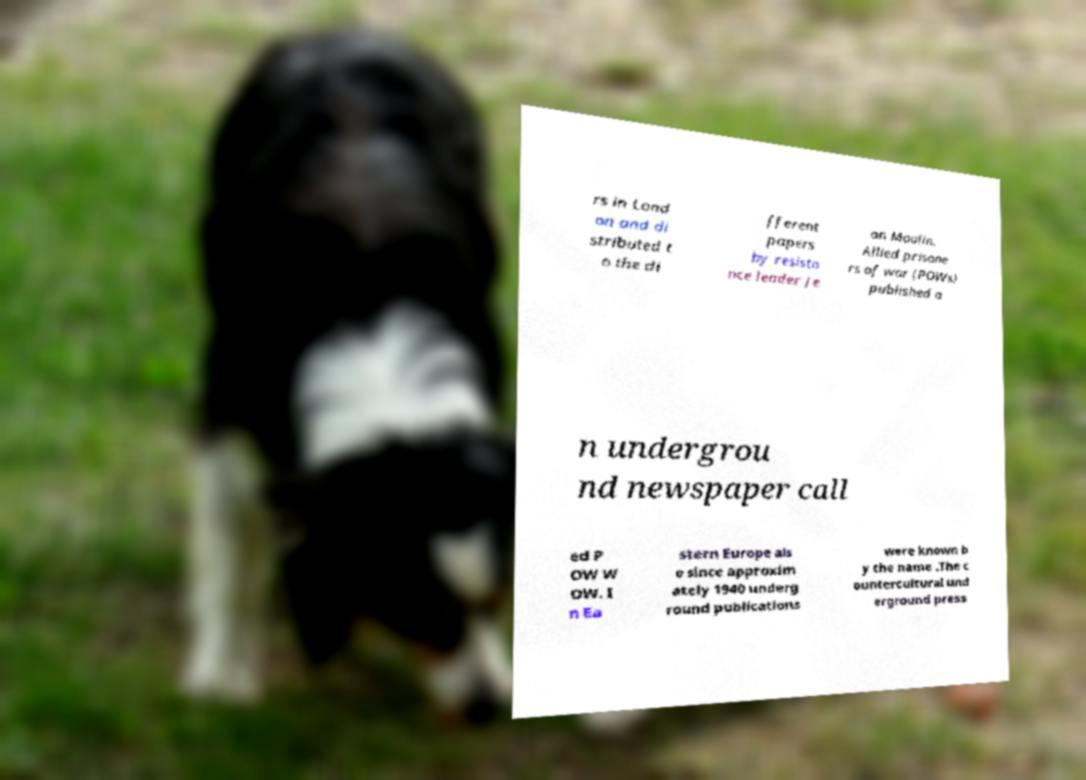For documentation purposes, I need the text within this image transcribed. Could you provide that? rs in Lond on and di stributed t o the di fferent papers by resista nce leader Je an Moulin. Allied prisone rs of war (POWs) published a n undergrou nd newspaper call ed P OW W OW. I n Ea stern Europe als o since approxim ately 1940 underg round publications were known b y the name .The c ountercultural und erground press 